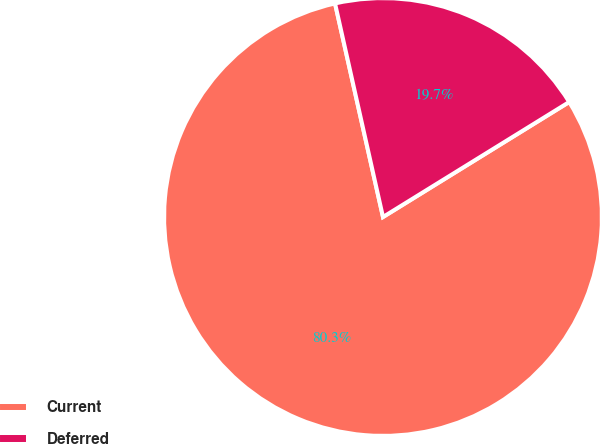Convert chart to OTSL. <chart><loc_0><loc_0><loc_500><loc_500><pie_chart><fcel>Current<fcel>Deferred<nl><fcel>80.29%<fcel>19.71%<nl></chart> 